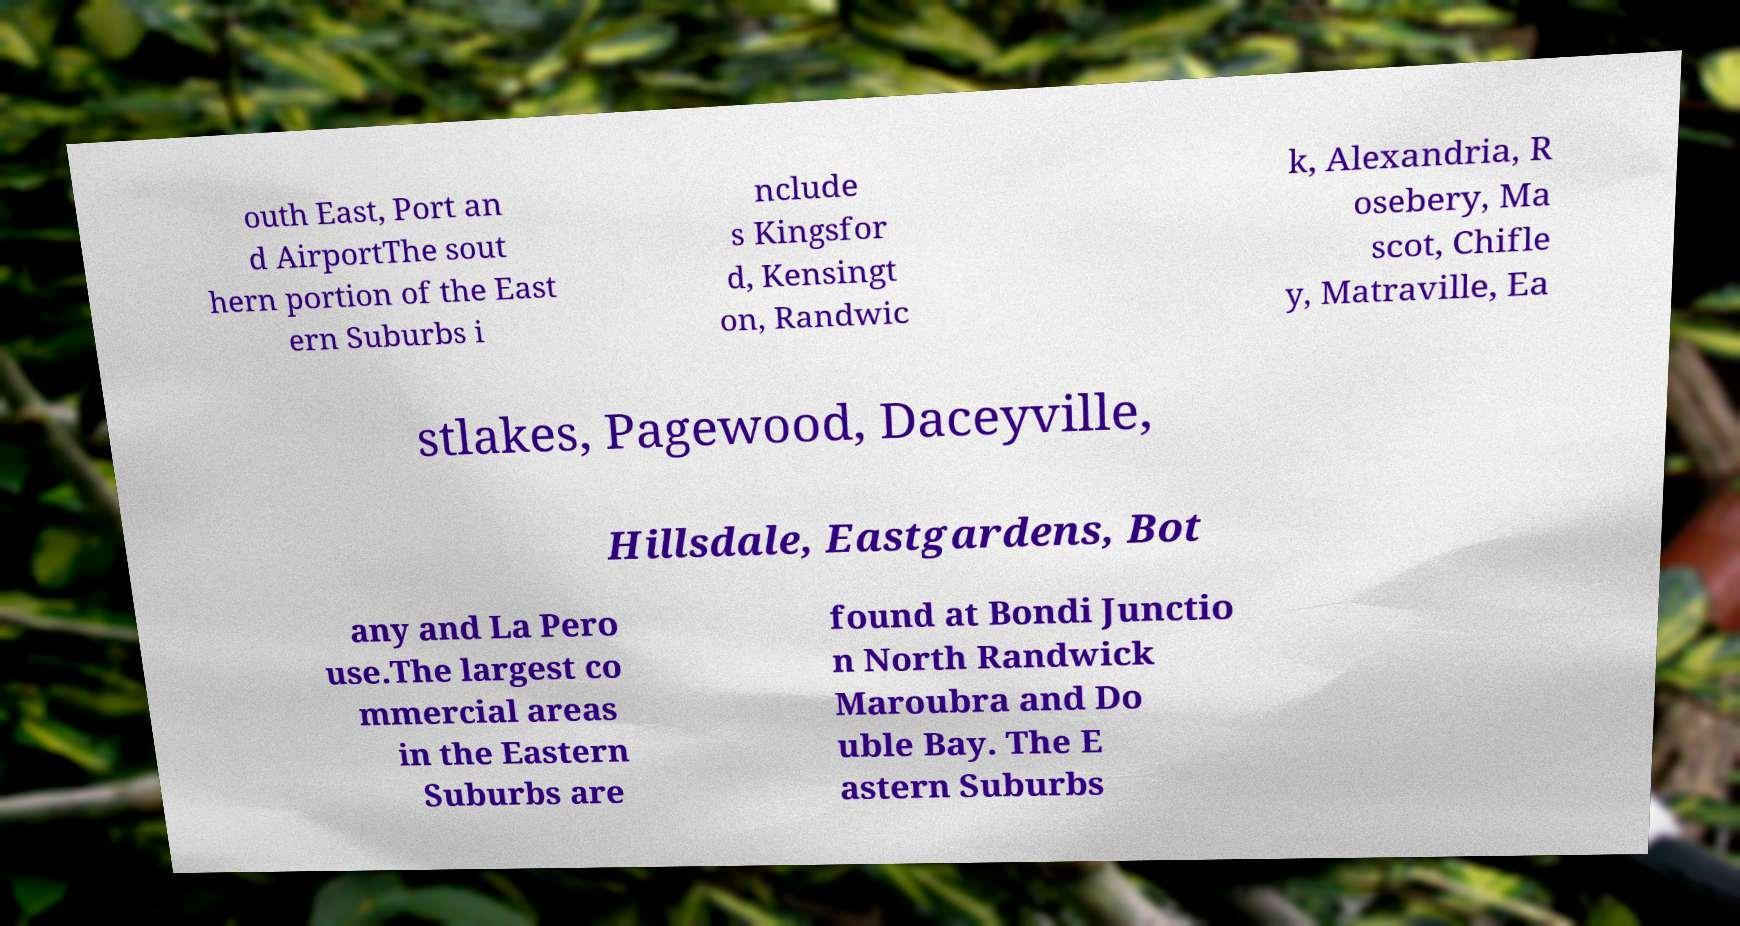For documentation purposes, I need the text within this image transcribed. Could you provide that? outh East, Port an d AirportThe sout hern portion of the East ern Suburbs i nclude s Kingsfor d, Kensingt on, Randwic k, Alexandria, R osebery, Ma scot, Chifle y, Matraville, Ea stlakes, Pagewood, Daceyville, Hillsdale, Eastgardens, Bot any and La Pero use.The largest co mmercial areas in the Eastern Suburbs are found at Bondi Junctio n North Randwick Maroubra and Do uble Bay. The E astern Suburbs 